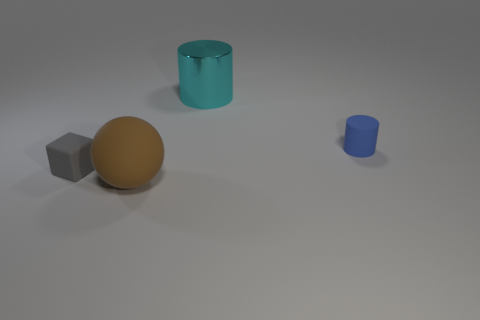There is a object that is behind the gray cube and to the left of the tiny cylinder; what material is it?
Provide a short and direct response. Metal. Do the object that is on the right side of the cyan shiny thing and the tiny gray block have the same size?
Your answer should be compact. Yes. What is the material of the tiny gray thing?
Your answer should be very brief. Rubber. There is a large thing that is on the left side of the shiny object; what color is it?
Provide a succinct answer. Brown. What number of big objects are brown objects or cyan metallic things?
Offer a terse response. 2. There is a object that is to the right of the shiny object; does it have the same color as the small thing that is on the left side of the cyan metallic cylinder?
Provide a short and direct response. No. How many purple things are metallic things or rubber spheres?
Make the answer very short. 0. There is a small gray rubber thing; does it have the same shape as the matte thing that is to the right of the metal cylinder?
Keep it short and to the point. No. What is the shape of the big metallic thing?
Make the answer very short. Cylinder. There is a thing that is the same size as the blue cylinder; what is it made of?
Your answer should be very brief. Rubber. 